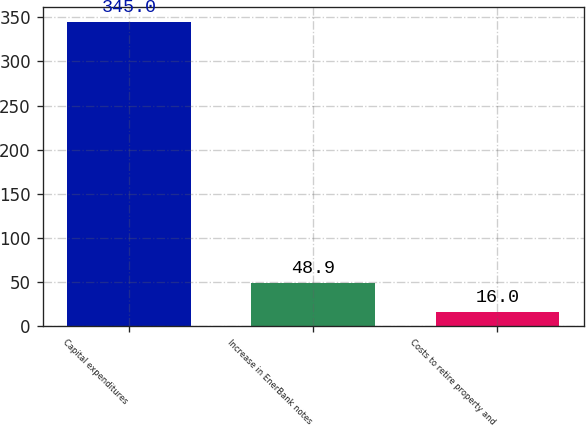Convert chart to OTSL. <chart><loc_0><loc_0><loc_500><loc_500><bar_chart><fcel>Capital expenditures<fcel>Increase in EnerBank notes<fcel>Costs to retire property and<nl><fcel>345<fcel>48.9<fcel>16<nl></chart> 